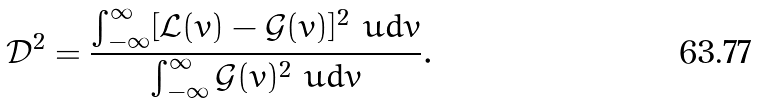<formula> <loc_0><loc_0><loc_500><loc_500>\mathcal { D } ^ { 2 } = \frac { \int _ { - \infty } ^ { \infty } [ \mathcal { L } ( v ) - \mathcal { G } ( v ) ] ^ { 2 } \ u d v } { \int _ { - \infty } ^ { \infty } \mathcal { G } ( v ) ^ { 2 } \ u d v } .</formula> 